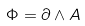Convert formula to latex. <formula><loc_0><loc_0><loc_500><loc_500>\Phi = \partial \wedge A</formula> 